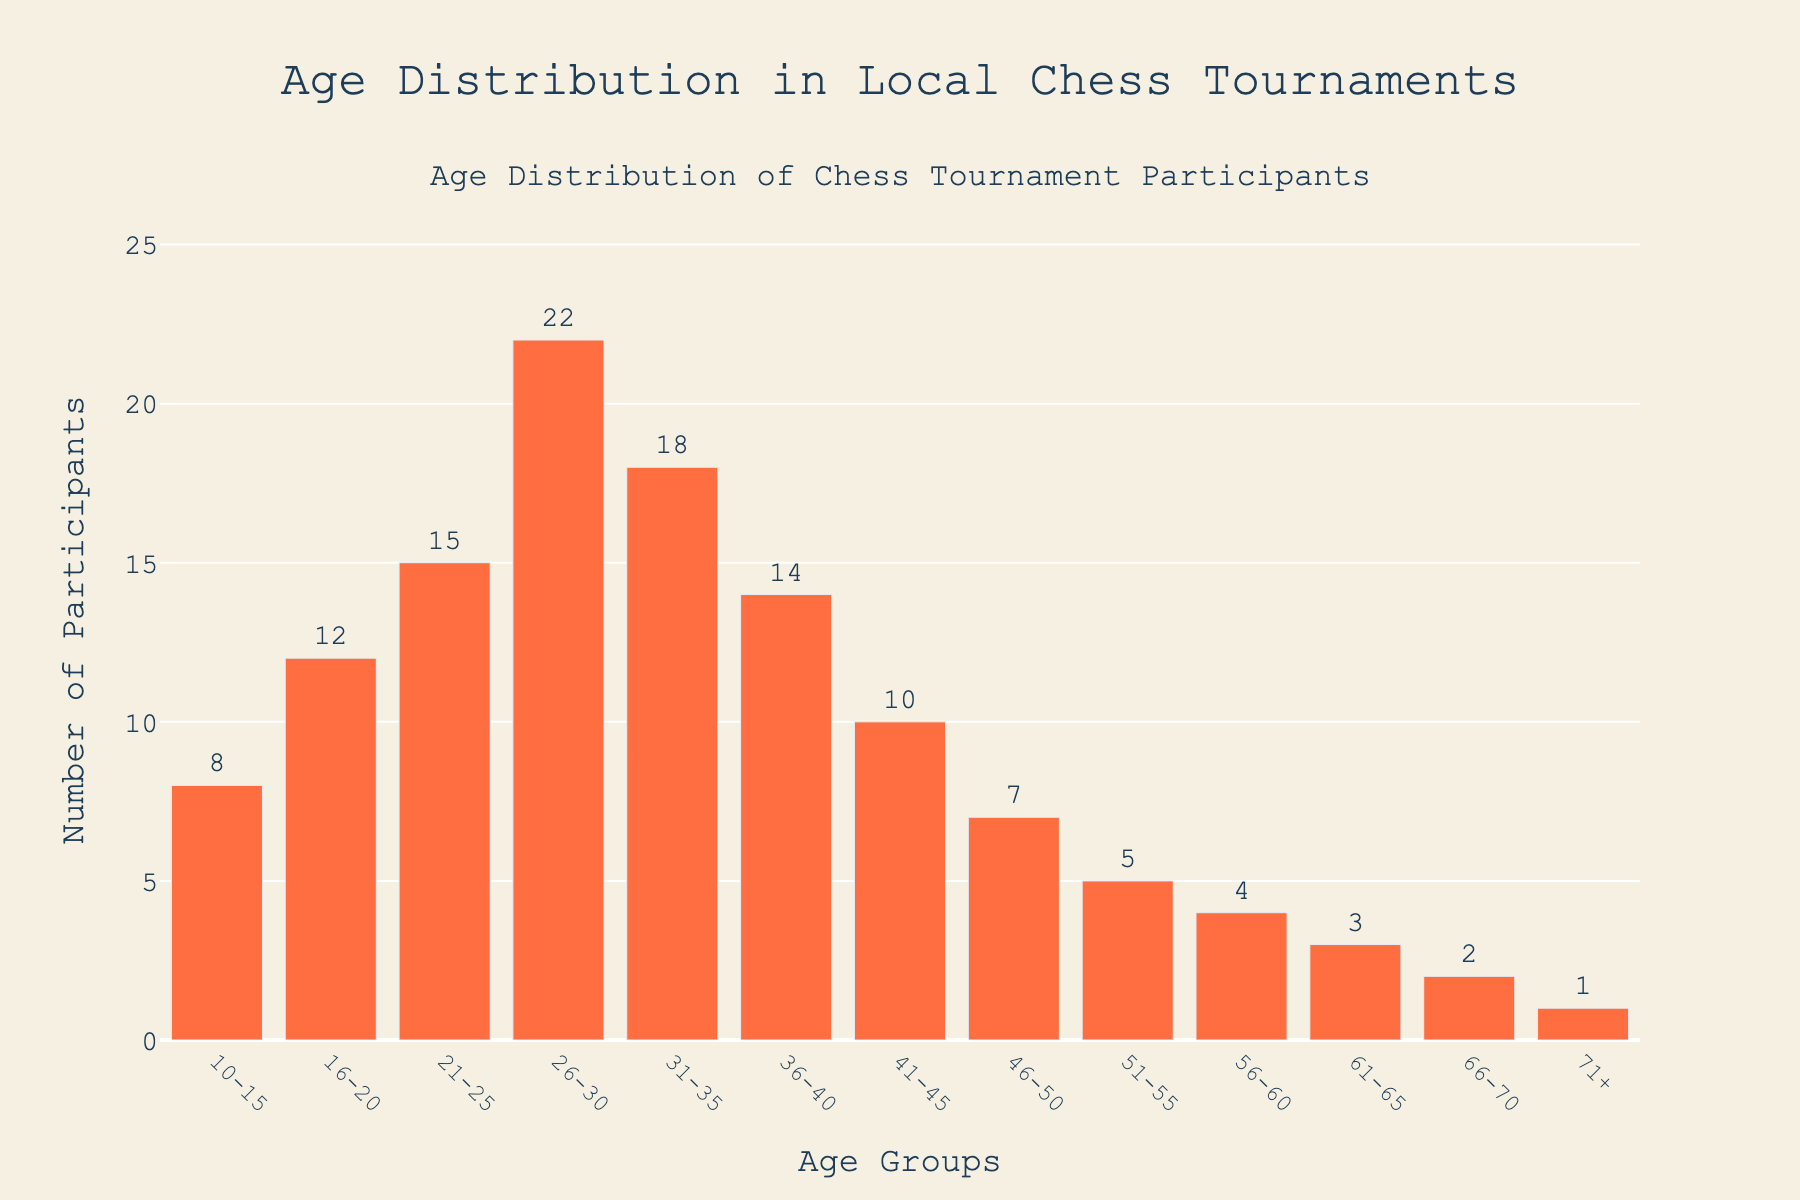What is the title of the figure? The title is located at the top of the figure and is usually descriptive, summarizing what the figure represents. The title reads, "Age Distribution in Local Chess Tournaments."
Answer: Age Distribution in Local Chess Tournaments How many participants are in the age group 31-35? Look for the bar labeled "31-35" on the x-axis and check its height or the text label at the top. The text label indicates that there are 18 participants in this age group.
Answer: 18 Which age group has the highest number of participants? Identify the tallest bar in the histogram, which represents the age group with the highest frequency. The bar labeled "26-30" is the tallest.
Answer: 26-30 What is the total number of participants across all age groups? Sum the frequencies of all age groups: 8 + 12 + 15 + 22 + 18 + 14 + 10 + 7 + 5 + 4 + 3 + 2 + 1. The total is 121.
Answer: 121 What is the range of ages represented in the figure? The range is determined by the smallest and largest age groups provided along the x-axis. The smallest group is "10-15" and the largest is "71+."
Answer: 10-71+ How many participants are aged 60 and above? Sum the frequencies of the age groups "61-65," "66-70," and "71+." Adding 3 (61-65), 2 (66-70), and 1 (71+) gives a total of 6 participants.
Answer: 6 What is the average number of participants in each age group? The total number of participants (121) divided by the number of age groups (13) gives the average: 121 / 13 ≈ 9.31.
Answer: ~9.31 Are there more participants in the age group 21-25 or 41-45? Compare the heights of the bars for the age groups "21-25" (15 participants) and "41-45" (10 participants). The age group "21-25" has more participants.
Answer: 21-25 Which age group shows the least number of participants? Identify the shortest bar in the histogram, which represents the age group with the least frequency. The bar labeled "71+" is the shortest.
Answer: 71+ What percentage of participants are in the age group 21-30? Combine the frequencies for "21-25" (15 participants) and "26-30" (22 participants) to get 37. Divide by the total number of participants (121) and multiply by 100: (37 / 121) * 100 ≈ 30.58%.
Answer: ~30.58% 